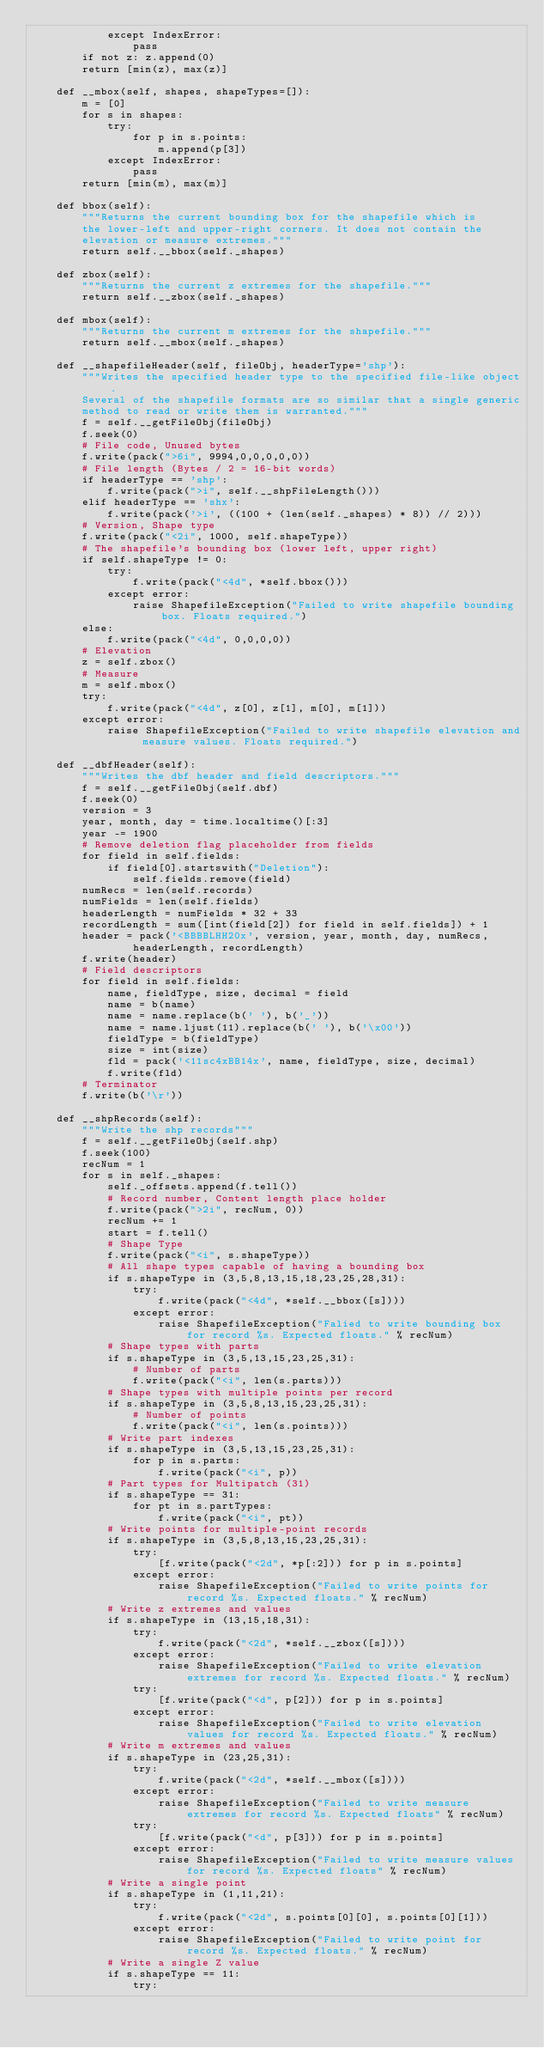Convert code to text. <code><loc_0><loc_0><loc_500><loc_500><_Python_>            except IndexError:
                pass
        if not z: z.append(0)
        return [min(z), max(z)]

    def __mbox(self, shapes, shapeTypes=[]):
        m = [0]
        for s in shapes:
            try:
                for p in s.points:
                    m.append(p[3])
            except IndexError:
                pass
        return [min(m), max(m)]

    def bbox(self):
        """Returns the current bounding box for the shapefile which is
        the lower-left and upper-right corners. It does not contain the
        elevation or measure extremes."""
        return self.__bbox(self._shapes)

    def zbox(self):
        """Returns the current z extremes for the shapefile."""
        return self.__zbox(self._shapes)

    def mbox(self):
        """Returns the current m extremes for the shapefile."""
        return self.__mbox(self._shapes)

    def __shapefileHeader(self, fileObj, headerType='shp'):
        """Writes the specified header type to the specified file-like object.
        Several of the shapefile formats are so similar that a single generic
        method to read or write them is warranted."""
        f = self.__getFileObj(fileObj)
        f.seek(0)
        # File code, Unused bytes
        f.write(pack(">6i", 9994,0,0,0,0,0))
        # File length (Bytes / 2 = 16-bit words)
        if headerType == 'shp':
            f.write(pack(">i", self.__shpFileLength()))
        elif headerType == 'shx':
            f.write(pack('>i', ((100 + (len(self._shapes) * 8)) // 2)))
        # Version, Shape type
        f.write(pack("<2i", 1000, self.shapeType))
        # The shapefile's bounding box (lower left, upper right)
        if self.shapeType != 0:
            try:
                f.write(pack("<4d", *self.bbox()))
            except error:
                raise ShapefileException("Failed to write shapefile bounding box. Floats required.")
        else:
            f.write(pack("<4d", 0,0,0,0))
        # Elevation
        z = self.zbox()
        # Measure
        m = self.mbox()
        try:
            f.write(pack("<4d", z[0], z[1], m[0], m[1]))
        except error:
            raise ShapefileException("Failed to write shapefile elevation and measure values. Floats required.")

    def __dbfHeader(self):
        """Writes the dbf header and field descriptors."""
        f = self.__getFileObj(self.dbf)
        f.seek(0)
        version = 3
        year, month, day = time.localtime()[:3]
        year -= 1900
        # Remove deletion flag placeholder from fields
        for field in self.fields:
            if field[0].startswith("Deletion"):
                self.fields.remove(field)
        numRecs = len(self.records)
        numFields = len(self.fields)
        headerLength = numFields * 32 + 33
        recordLength = sum([int(field[2]) for field in self.fields]) + 1
        header = pack('<BBBBLHH20x', version, year, month, day, numRecs,
                headerLength, recordLength)
        f.write(header)
        # Field descriptors
        for field in self.fields:
            name, fieldType, size, decimal = field
            name = b(name)
            name = name.replace(b(' '), b('_'))
            name = name.ljust(11).replace(b(' '), b('\x00'))
            fieldType = b(fieldType)
            size = int(size)
            fld = pack('<11sc4xBB14x', name, fieldType, size, decimal)
            f.write(fld)
        # Terminator
        f.write(b('\r'))

    def __shpRecords(self):
        """Write the shp records"""
        f = self.__getFileObj(self.shp)
        f.seek(100)
        recNum = 1
        for s in self._shapes:
            self._offsets.append(f.tell())
            # Record number, Content length place holder
            f.write(pack(">2i", recNum, 0))
            recNum += 1
            start = f.tell()
            # Shape Type
            f.write(pack("<i", s.shapeType))
            # All shape types capable of having a bounding box
            if s.shapeType in (3,5,8,13,15,18,23,25,28,31):
                try:
                    f.write(pack("<4d", *self.__bbox([s])))
                except error:
                    raise ShapefileException("Falied to write bounding box for record %s. Expected floats." % recNum)
            # Shape types with parts
            if s.shapeType in (3,5,13,15,23,25,31):
                # Number of parts
                f.write(pack("<i", len(s.parts)))
            # Shape types with multiple points per record
            if s.shapeType in (3,5,8,13,15,23,25,31):
                # Number of points
                f.write(pack("<i", len(s.points)))
            # Write part indexes
            if s.shapeType in (3,5,13,15,23,25,31):
                for p in s.parts:
                    f.write(pack("<i", p))
            # Part types for Multipatch (31)
            if s.shapeType == 31:
                for pt in s.partTypes:
                    f.write(pack("<i", pt))
            # Write points for multiple-point records
            if s.shapeType in (3,5,8,13,15,23,25,31):
                try:
                    [f.write(pack("<2d", *p[:2])) for p in s.points]
                except error:
                    raise ShapefileException("Failed to write points for record %s. Expected floats." % recNum)
            # Write z extremes and values
            if s.shapeType in (13,15,18,31):
                try:
                    f.write(pack("<2d", *self.__zbox([s])))
                except error:
                    raise ShapefileException("Failed to write elevation extremes for record %s. Expected floats." % recNum)
                try:
                    [f.write(pack("<d", p[2])) for p in s.points]
                except error:
                    raise ShapefileException("Failed to write elevation values for record %s. Expected floats." % recNum)
            # Write m extremes and values
            if s.shapeType in (23,25,31):
                try:
                    f.write(pack("<2d", *self.__mbox([s])))
                except error:
                    raise ShapefileException("Failed to write measure extremes for record %s. Expected floats" % recNum)
                try:
                    [f.write(pack("<d", p[3])) for p in s.points]
                except error:
                    raise ShapefileException("Failed to write measure values for record %s. Expected floats" % recNum)
            # Write a single point
            if s.shapeType in (1,11,21):
                try:
                    f.write(pack("<2d", s.points[0][0], s.points[0][1]))
                except error:
                    raise ShapefileException("Failed to write point for record %s. Expected floats." % recNum)
            # Write a single Z value
            if s.shapeType == 11:
                try:</code> 